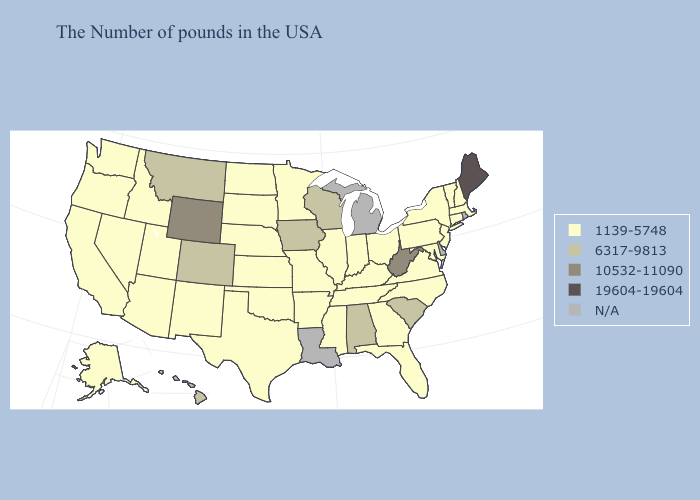Does Arkansas have the lowest value in the South?
Write a very short answer. Yes. Name the states that have a value in the range N/A?
Short answer required. Rhode Island, Delaware, Michigan, Louisiana. Does Wisconsin have the lowest value in the USA?
Concise answer only. No. What is the lowest value in the USA?
Answer briefly. 1139-5748. What is the lowest value in the USA?
Keep it brief. 1139-5748. Does the first symbol in the legend represent the smallest category?
Give a very brief answer. Yes. Name the states that have a value in the range N/A?
Short answer required. Rhode Island, Delaware, Michigan, Louisiana. Which states hav the highest value in the South?
Answer briefly. West Virginia. Does Connecticut have the lowest value in the Northeast?
Be succinct. Yes. Which states have the highest value in the USA?
Quick response, please. Maine. How many symbols are there in the legend?
Concise answer only. 5. Name the states that have a value in the range 1139-5748?
Keep it brief. Massachusetts, New Hampshire, Vermont, Connecticut, New York, New Jersey, Maryland, Pennsylvania, Virginia, North Carolina, Ohio, Florida, Georgia, Kentucky, Indiana, Tennessee, Illinois, Mississippi, Missouri, Arkansas, Minnesota, Kansas, Nebraska, Oklahoma, Texas, South Dakota, North Dakota, New Mexico, Utah, Arizona, Idaho, Nevada, California, Washington, Oregon, Alaska. 